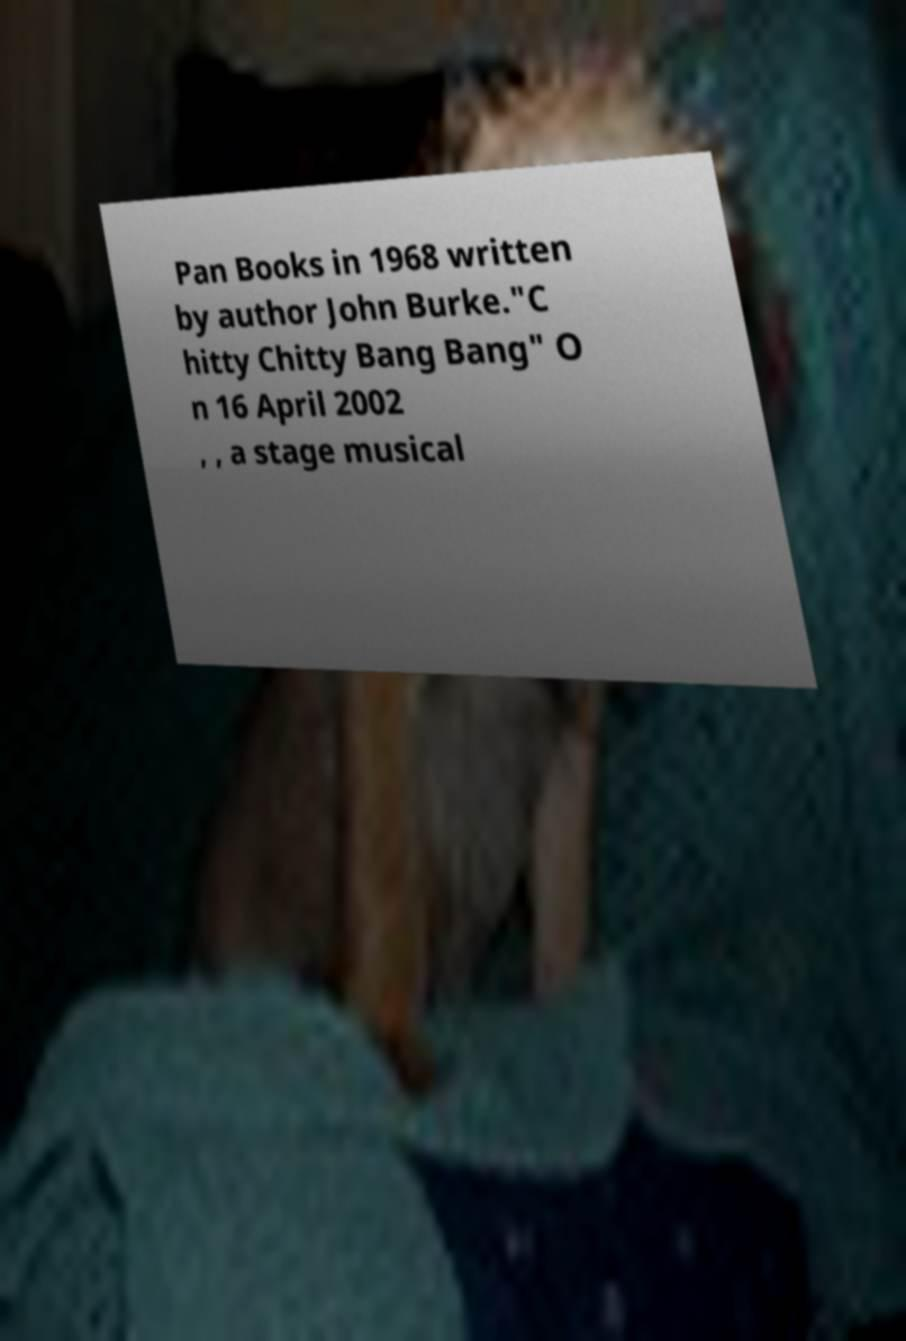For documentation purposes, I need the text within this image transcribed. Could you provide that? Pan Books in 1968 written by author John Burke."C hitty Chitty Bang Bang" O n 16 April 2002 , , a stage musical 